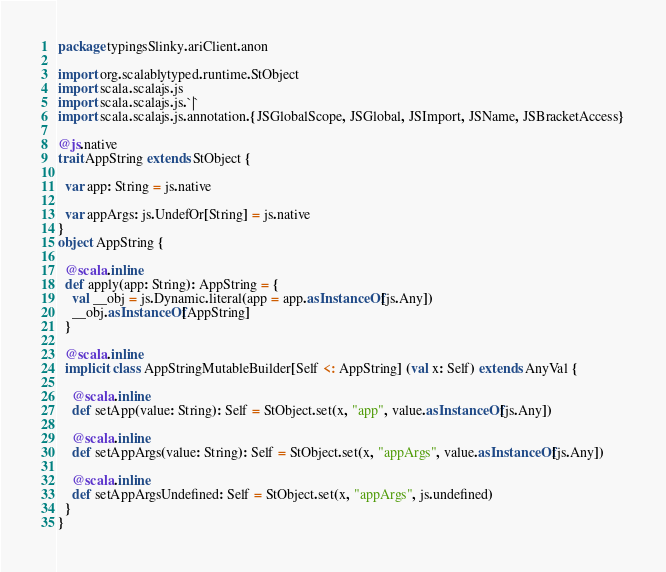Convert code to text. <code><loc_0><loc_0><loc_500><loc_500><_Scala_>package typingsSlinky.ariClient.anon

import org.scalablytyped.runtime.StObject
import scala.scalajs.js
import scala.scalajs.js.`|`
import scala.scalajs.js.annotation.{JSGlobalScope, JSGlobal, JSImport, JSName, JSBracketAccess}

@js.native
trait AppString extends StObject {
  
  var app: String = js.native
  
  var appArgs: js.UndefOr[String] = js.native
}
object AppString {
  
  @scala.inline
  def apply(app: String): AppString = {
    val __obj = js.Dynamic.literal(app = app.asInstanceOf[js.Any])
    __obj.asInstanceOf[AppString]
  }
  
  @scala.inline
  implicit class AppStringMutableBuilder[Self <: AppString] (val x: Self) extends AnyVal {
    
    @scala.inline
    def setApp(value: String): Self = StObject.set(x, "app", value.asInstanceOf[js.Any])
    
    @scala.inline
    def setAppArgs(value: String): Self = StObject.set(x, "appArgs", value.asInstanceOf[js.Any])
    
    @scala.inline
    def setAppArgsUndefined: Self = StObject.set(x, "appArgs", js.undefined)
  }
}
</code> 